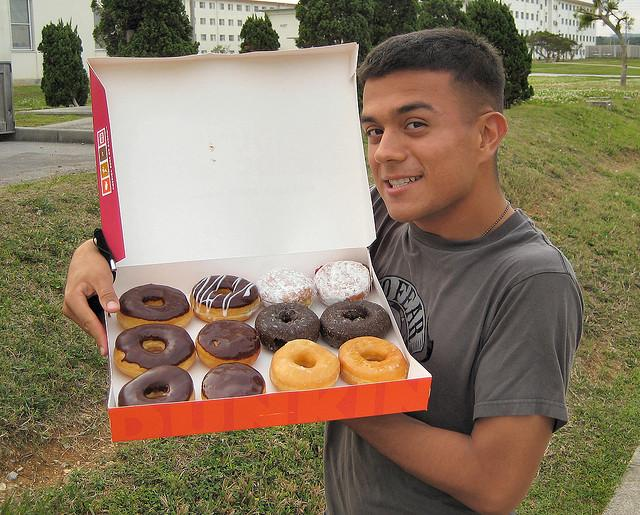What morning beverage is this company famous for? coffee 